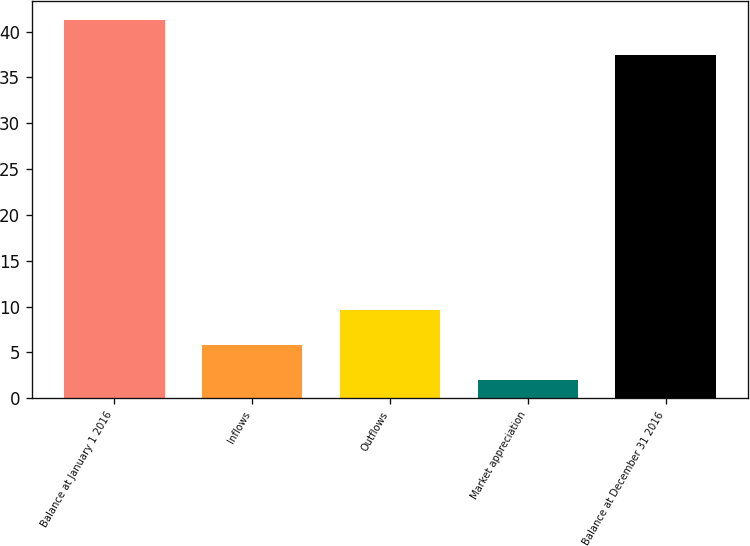Convert chart. <chart><loc_0><loc_0><loc_500><loc_500><bar_chart><fcel>Balance at January 1 2016<fcel>Inflows<fcel>Outflows<fcel>Market appreciation<fcel>Balance at December 31 2016<nl><fcel>41.29<fcel>5.79<fcel>9.58<fcel>2<fcel>37.5<nl></chart> 